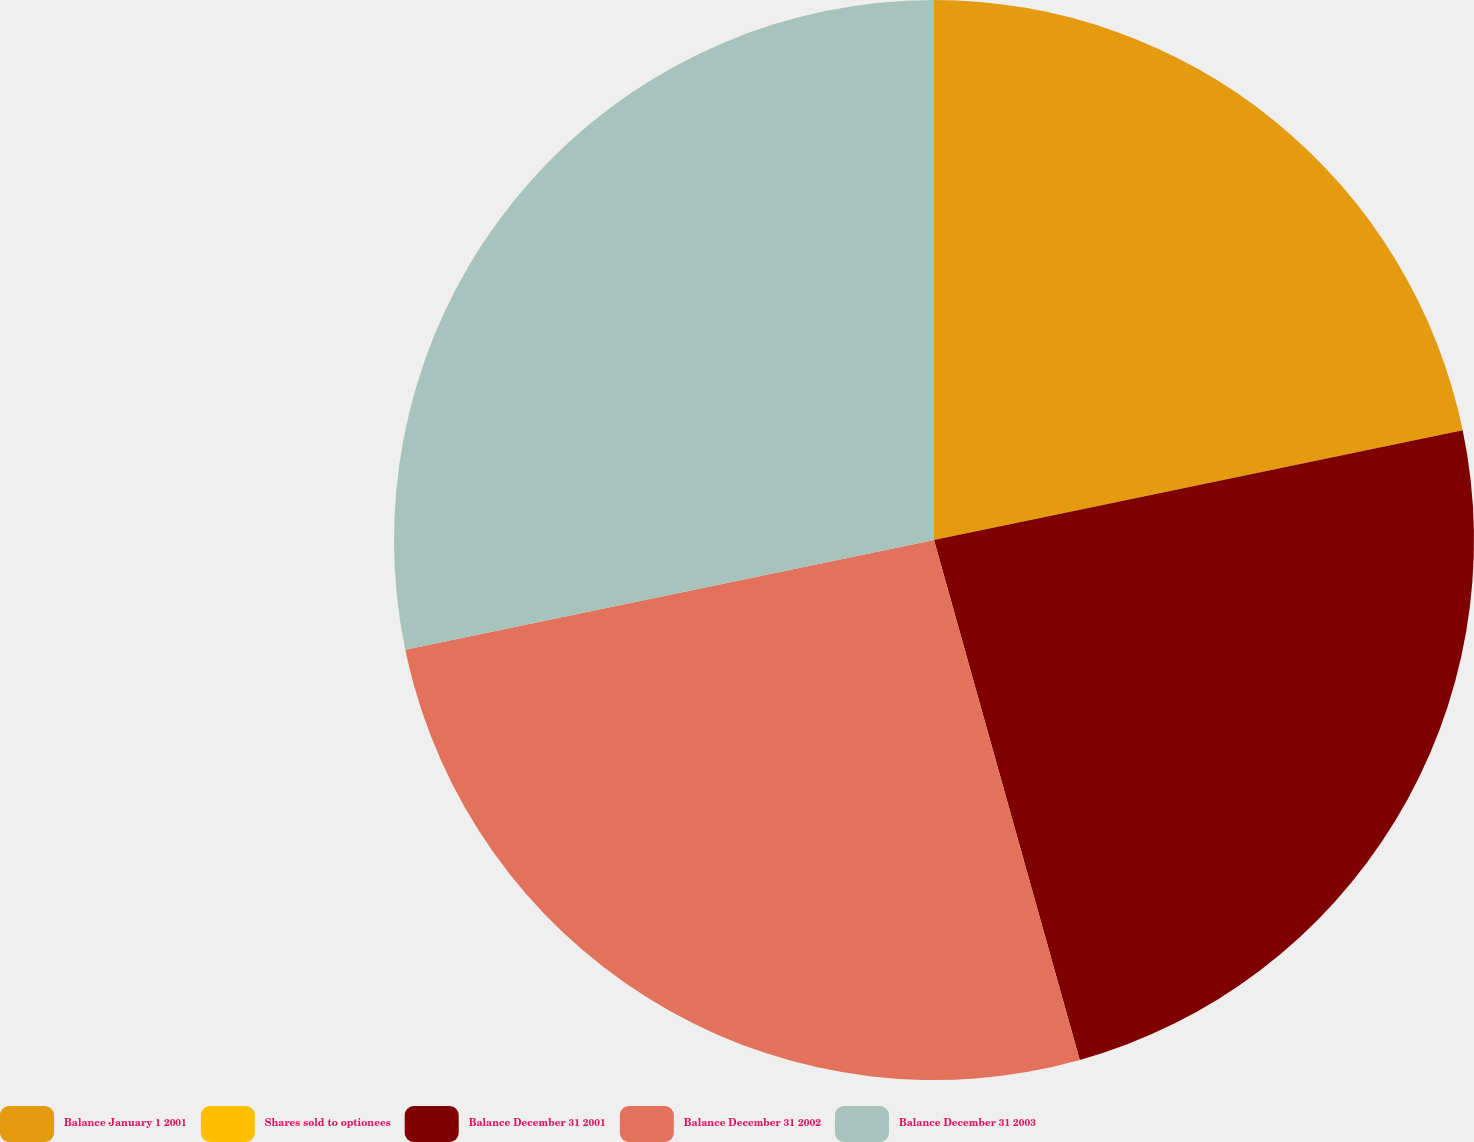Convert chart. <chart><loc_0><loc_0><loc_500><loc_500><pie_chart><fcel>Balance January 1 2001<fcel>Shares sold to optionees<fcel>Balance December 31 2001<fcel>Balance December 31 2002<fcel>Balance December 31 2003<nl><fcel>21.74%<fcel>0.0%<fcel>23.91%<fcel>26.09%<fcel>28.26%<nl></chart> 